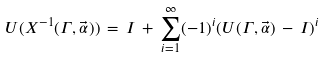<formula> <loc_0><loc_0><loc_500><loc_500>U ( { X } ^ { - 1 } ( \Gamma , \vec { \alpha } ) ) \, = \, I \, + \, \sum ^ { \infty } _ { i = 1 } ( - 1 ) ^ { i } ( U ( \Gamma , \vec { \alpha } ) \, - \, I ) ^ { i }</formula> 